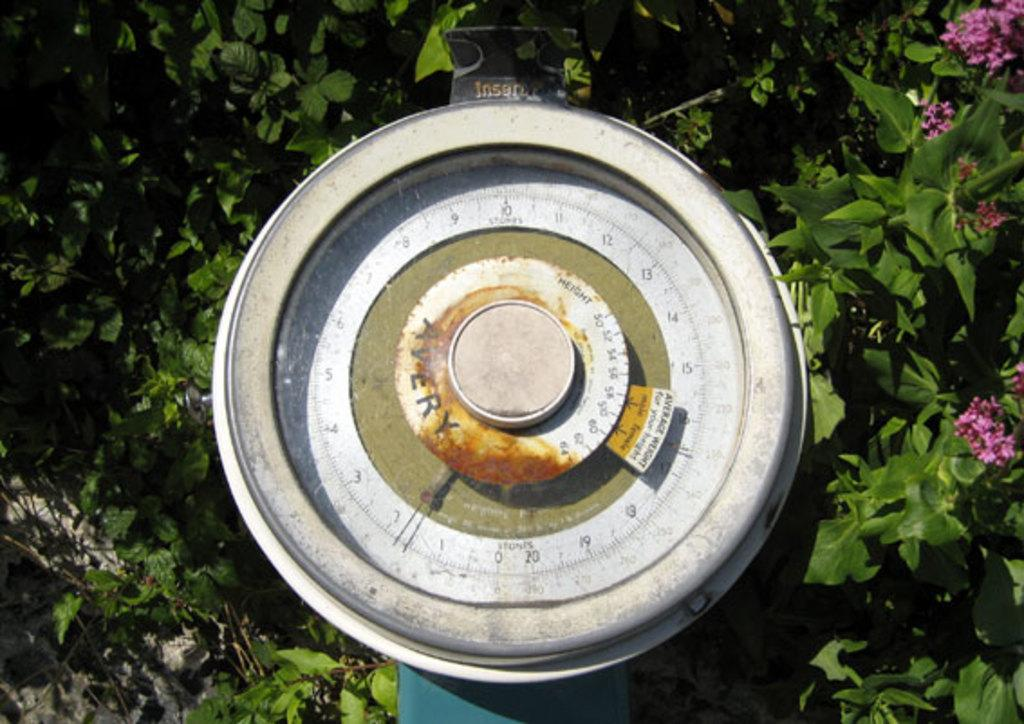What is the main object in the image? There is an object that looks like a measuring instrument in the image. What can be seen in the background of the image? There are trees and flowers in the background of the image. What type of skin condition can be seen on the measuring instrument in the image? There is no skin condition present on the measuring instrument in the image, as it is an inanimate object. 